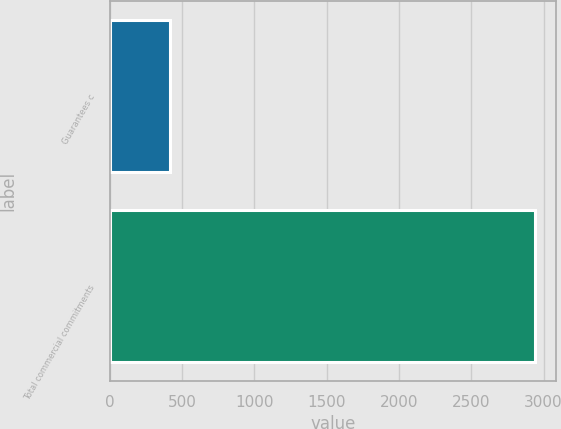Convert chart to OTSL. <chart><loc_0><loc_0><loc_500><loc_500><bar_chart><fcel>Guarantees c<fcel>Total commercial commitments<nl><fcel>416<fcel>2938<nl></chart> 